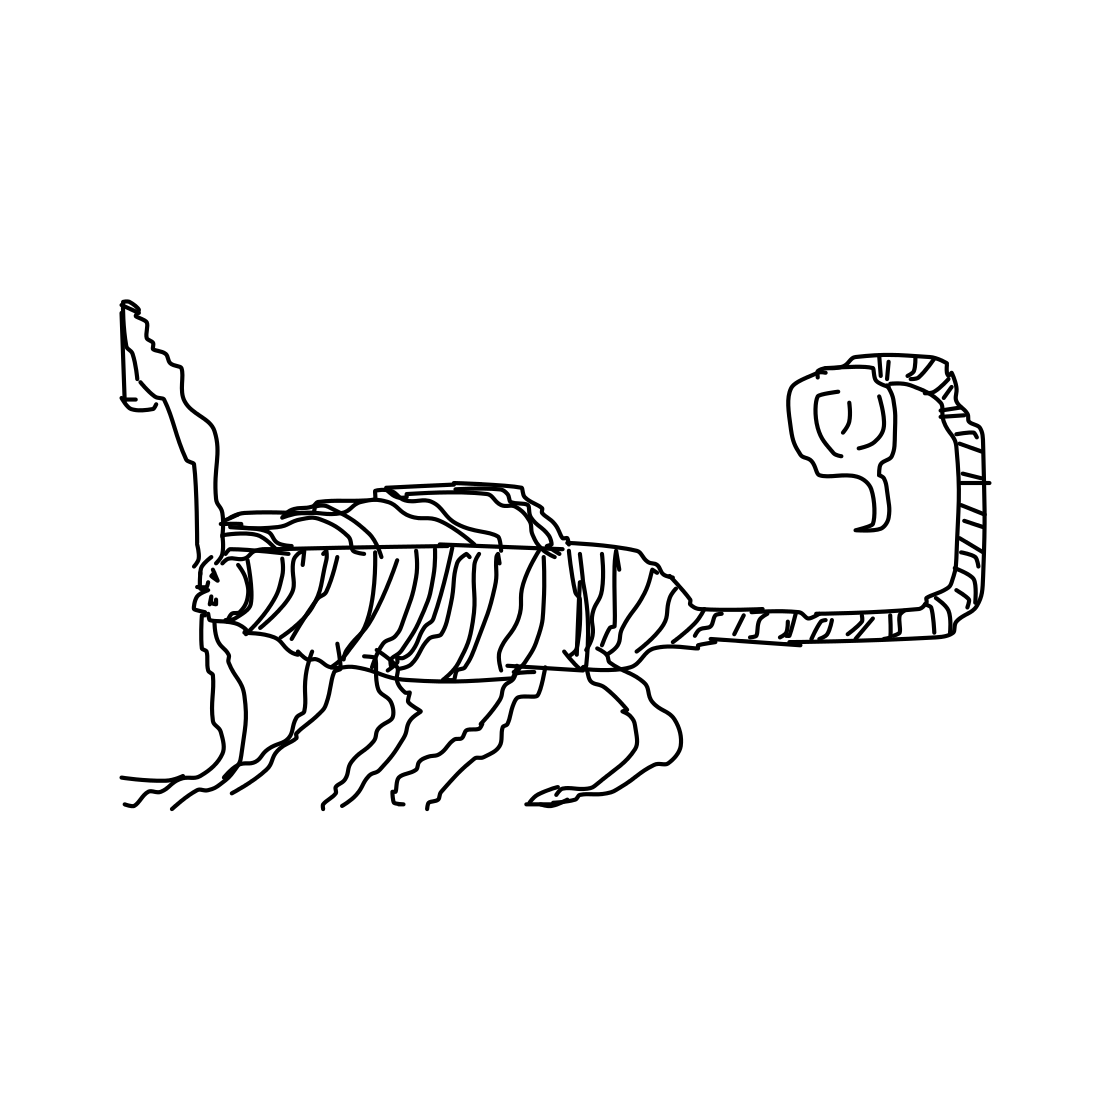What can you tell me about the mood or theme of this drawing? The drawing exudes a quirky and playful mood. It invites the viewer to interpret the image through their own imagination. The theme could be about the fluidity of identity and form, challenging our traditional understandings of animal figures. 